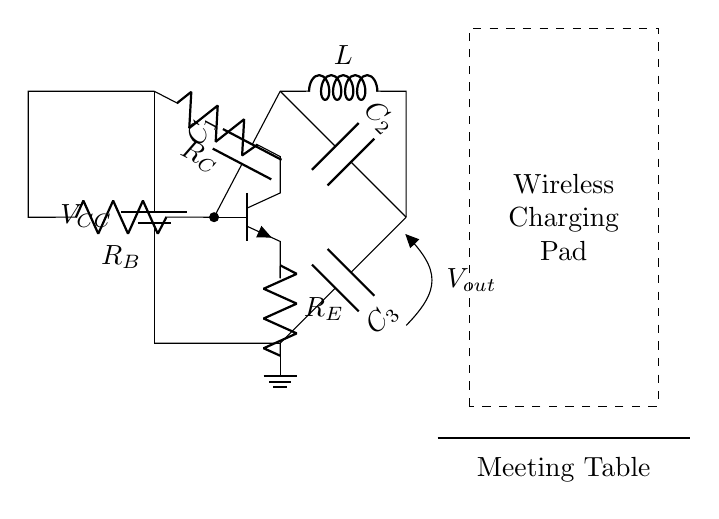What type of oscillator is represented in this circuit? The circuit represents a Colpitts oscillator, characterized by the use of capacitors and inductors for generating oscillations.
Answer: Colpitts oscillator What is the role of the inductor in this oscillator? The inductor is essential for energy storage and resonant frequency determination in the oscillator circuit, working in conjunction with capacitors.
Answer: Energy storage What are the variable parameters affecting the frequency of oscillation? The oscillation frequency is influenced by the values of the capacitors and the inductor, where changing these values alters the resonant frequency.
Answer: Capacitors and inductor values How many capacitors are present in this circuit? There are three capacitors labeled as C1, C2, and C3 in the circuit diagram, which are crucial for the oscillation process.
Answer: Three What is the purpose of resistor R_E in the Colpitts oscillator? Resistor R_E functions as an emitter resistor, providing stability and biasing for the transistor, which is pivotal in oscillation generation.
Answer: Stability and biasing What is the output voltage configuration in this oscillator circuit? The output voltage can be accessed at the node labeled V_out, allowing for monitoring or further processing of the oscillation signal.
Answer: V_out node How does the wireless charging pad integrate with this oscillator? The wireless charging pad is connected to the output of the oscillator circuit, allowing it to utilize the generated oscillation for wireless power transfer.
Answer: Power transfer 